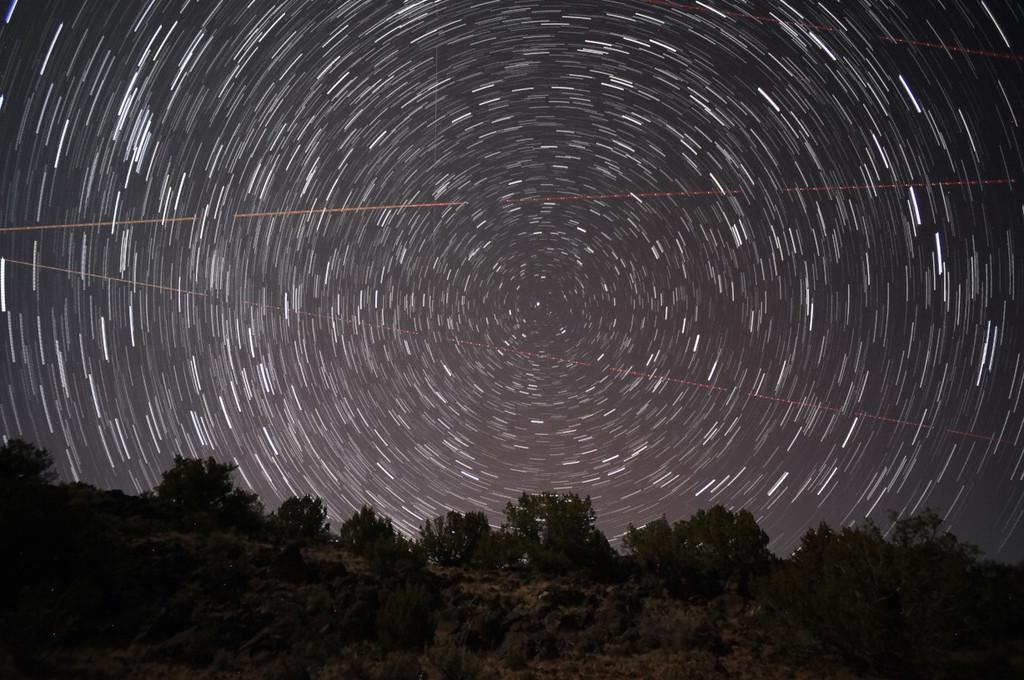What can be seen at the top of the image? The sky is visible in the image. What is located at the bottom of the image? There is a hill at the bottom of the image. What type of vegetation is present on the hill? The hill contains plants. What is the weight of the robin perched on the hill in the image? There is no robin present in the image, so it is not possible to determine its weight. 